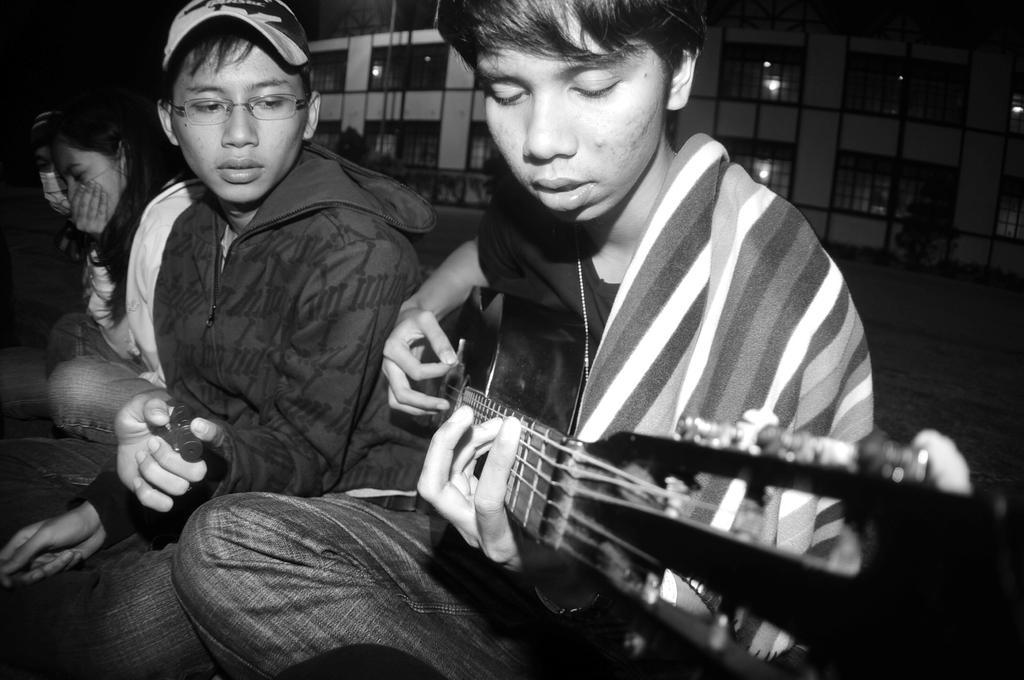Can you describe this image briefly? In this black and white picture we can see a man sitting and playing a guitar. We can see other men and a woman sitting beside to this man. On the background we can see a building. 